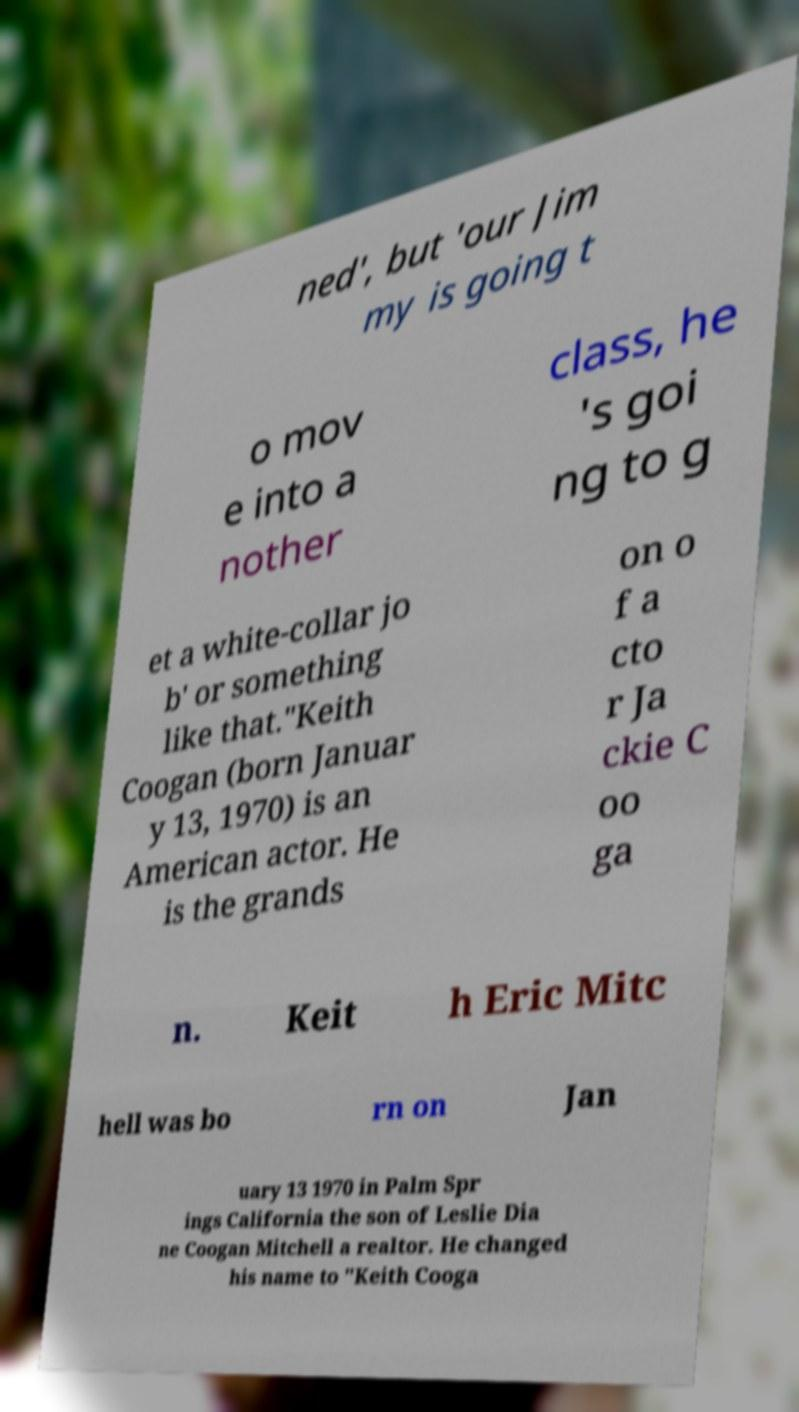Can you read and provide the text displayed in the image?This photo seems to have some interesting text. Can you extract and type it out for me? ned', but 'our Jim my is going t o mov e into a nother class, he 's goi ng to g et a white-collar jo b' or something like that."Keith Coogan (born Januar y 13, 1970) is an American actor. He is the grands on o f a cto r Ja ckie C oo ga n. Keit h Eric Mitc hell was bo rn on Jan uary 13 1970 in Palm Spr ings California the son of Leslie Dia ne Coogan Mitchell a realtor. He changed his name to "Keith Cooga 